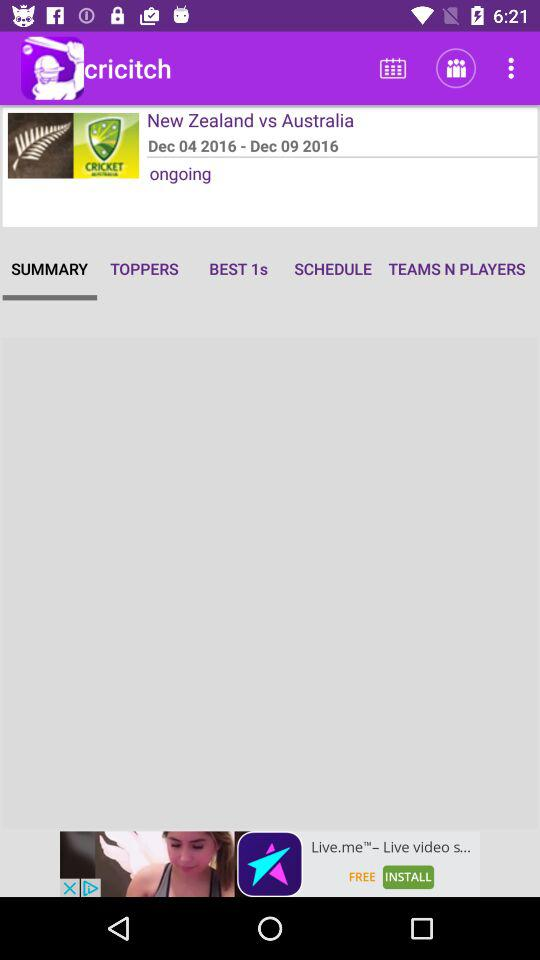Which tab am I on? You are on the "SUMMARY" tab. 